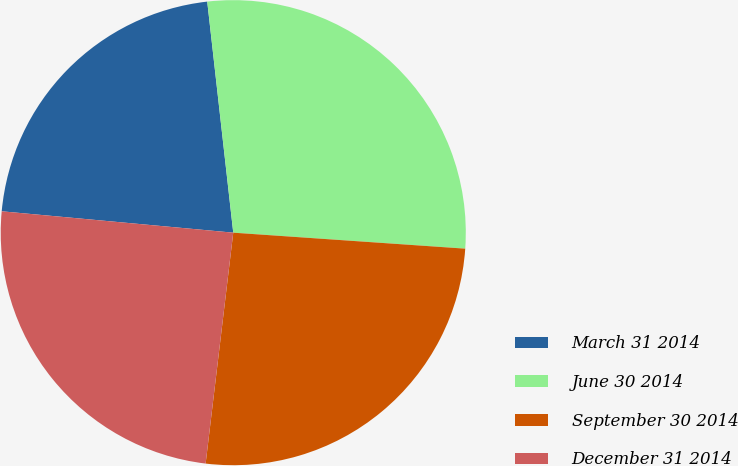<chart> <loc_0><loc_0><loc_500><loc_500><pie_chart><fcel>March 31 2014<fcel>June 30 2014<fcel>September 30 2014<fcel>December 31 2014<nl><fcel>21.75%<fcel>27.88%<fcel>25.8%<fcel>24.57%<nl></chart> 